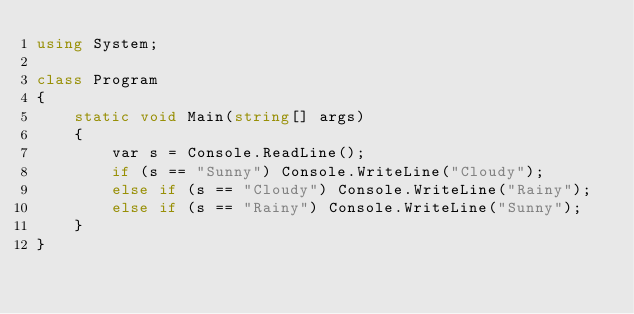Convert code to text. <code><loc_0><loc_0><loc_500><loc_500><_C#_>using System;

class Program
{
    static void Main(string[] args)
    {
        var s = Console.ReadLine();
        if (s == "Sunny") Console.WriteLine("Cloudy");
        else if (s == "Cloudy") Console.WriteLine("Rainy");
        else if (s == "Rainy") Console.WriteLine("Sunny");
    }
}
</code> 